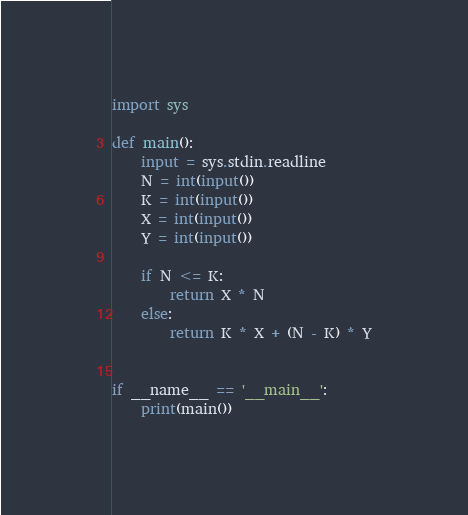Convert code to text. <code><loc_0><loc_0><loc_500><loc_500><_Python_>import sys

def main():
    input = sys.stdin.readline
    N = int(input())
    K = int(input())
    X = int(input())
    Y = int(input())

    if N <= K:
        return X * N
    else:
        return K * X + (N - K) * Y


if __name__ == '__main__':
    print(main())
</code> 